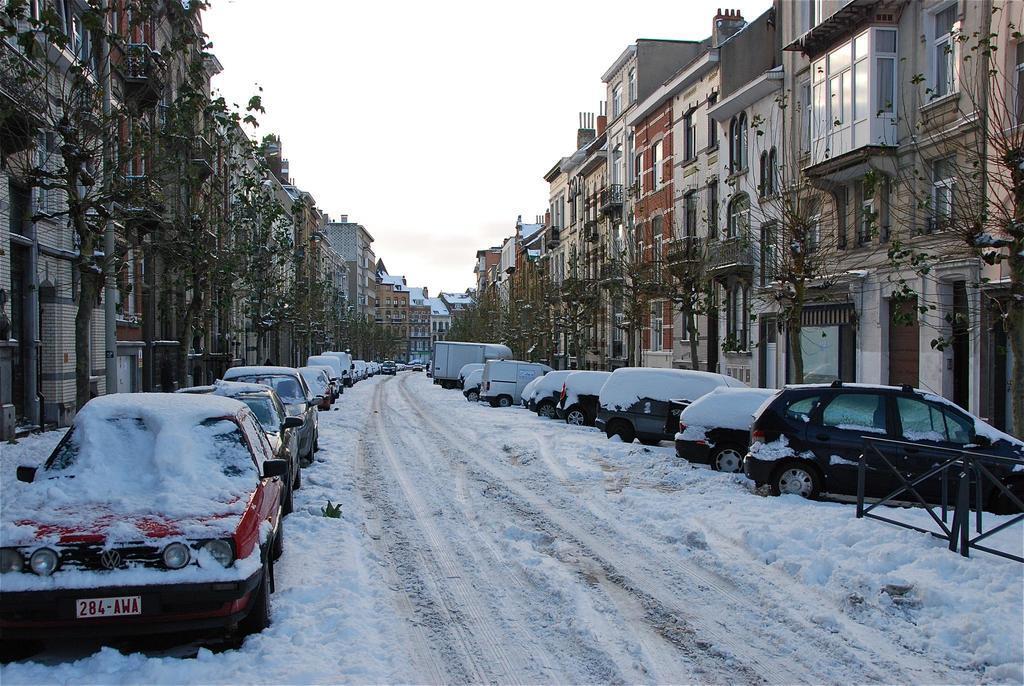How would you summarize this image in a sentence or two? In this image we can see a road covered with snow. On the sides of the road there are vehicles. On the vehicles there is snow. On the sides there are trees and buildings with windows. In the background there is sky. 